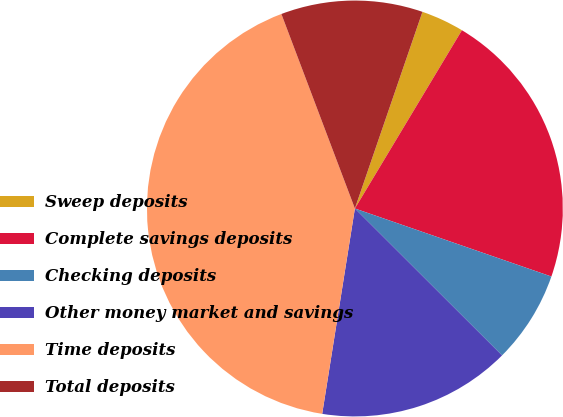<chart> <loc_0><loc_0><loc_500><loc_500><pie_chart><fcel>Sweep deposits<fcel>Complete savings deposits<fcel>Checking deposits<fcel>Other money market and savings<fcel>Time deposits<fcel>Total deposits<nl><fcel>3.34%<fcel>21.7%<fcel>7.18%<fcel>15.03%<fcel>41.74%<fcel>11.02%<nl></chart> 